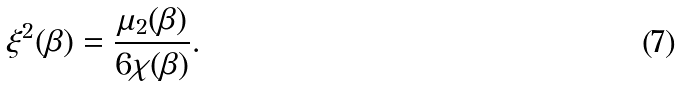Convert formula to latex. <formula><loc_0><loc_0><loc_500><loc_500>\xi ^ { 2 } ( \beta ) = \frac { \mu _ { 2 } ( \beta ) } { 6 \chi ( \beta ) } .</formula> 